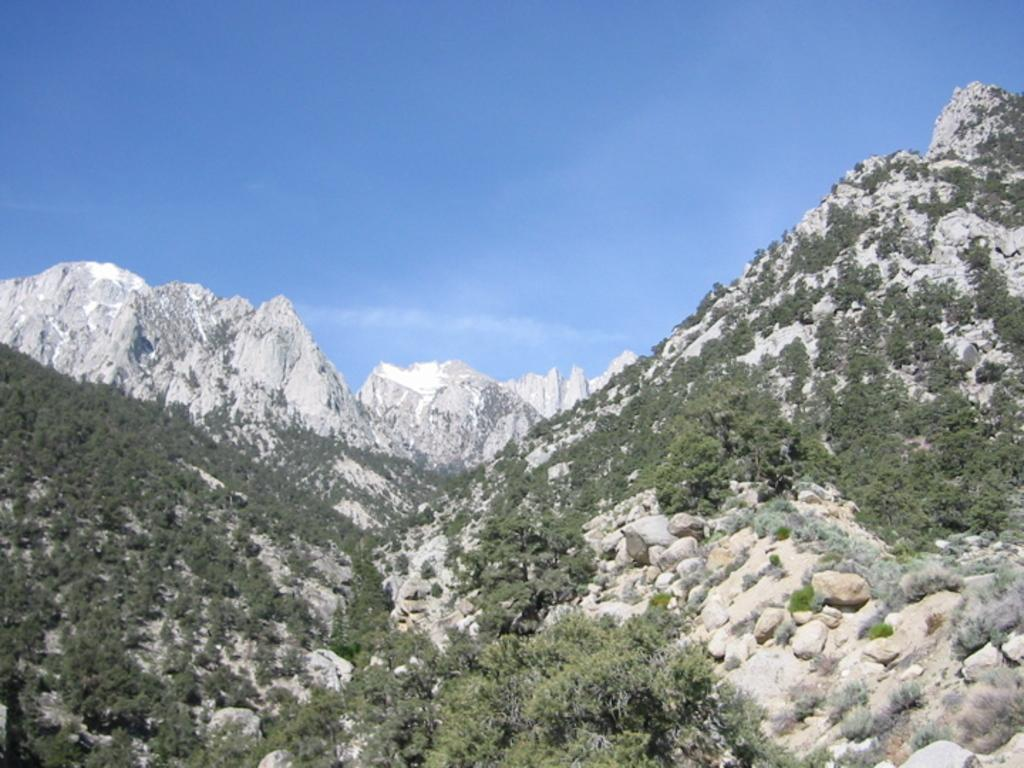What type of geographical feature is present in the image? There are mountains in the image. What can be seen on the mountains? There are trees on the mountains. What is visible in the background of the image? The sky is visible in the background of the image. How many pickles are hanging from the trees on the mountains in the image? There are no pickles present in the image; it features mountains with trees. What type of animals can be seen grazing on the mountains in the image? There are no animals visible in the image; it only shows mountains with trees and the sky in the background. 